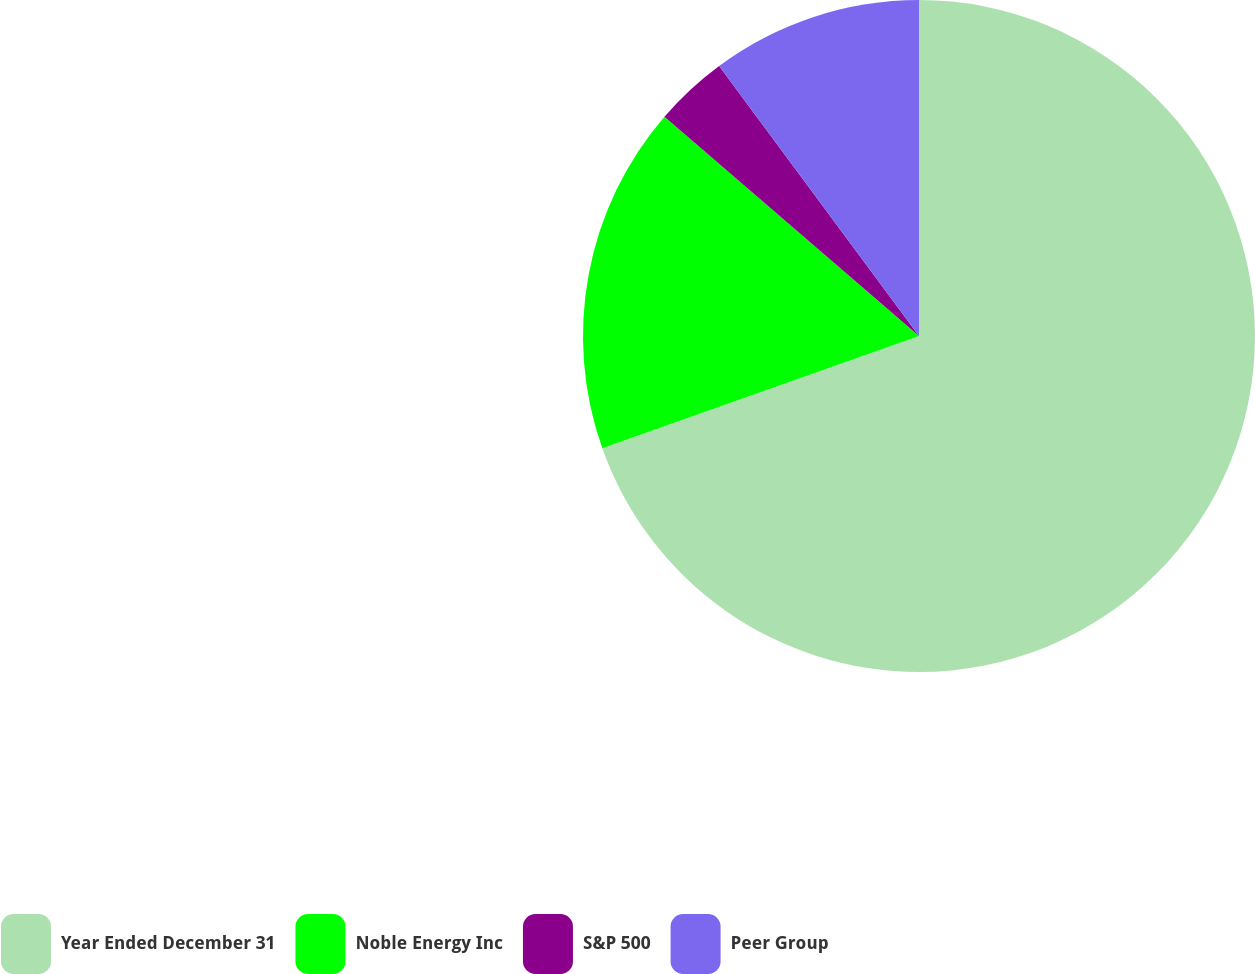Convert chart. <chart><loc_0><loc_0><loc_500><loc_500><pie_chart><fcel>Year Ended December 31<fcel>Noble Energy Inc<fcel>S&P 500<fcel>Peer Group<nl><fcel>69.58%<fcel>16.74%<fcel>3.54%<fcel>10.14%<nl></chart> 